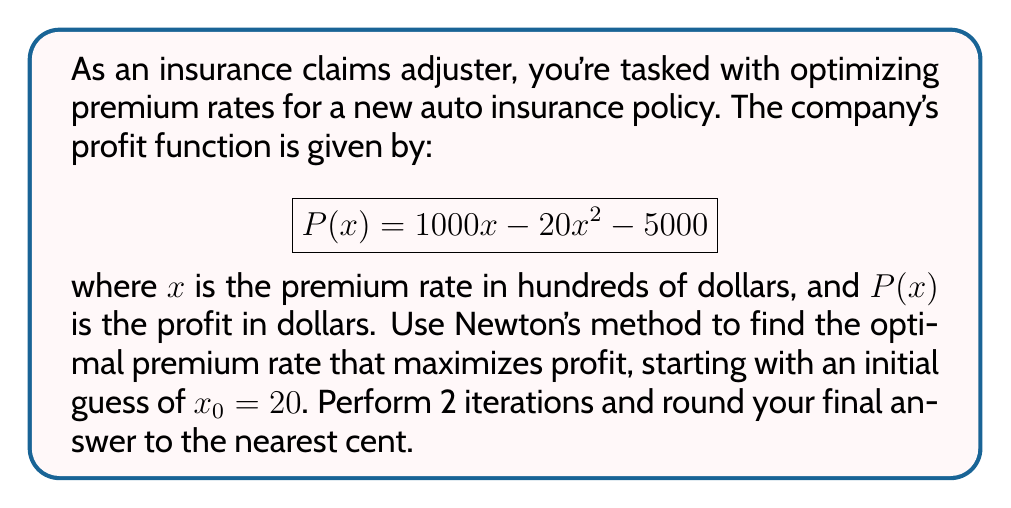What is the answer to this math problem? To find the maximum of the profit function using Newton's method:

1) First, we need to find the derivative of $P(x)$:
   $$P'(x) = 1000 - 40x$$

2) The second derivative is:
   $$P''(x) = -40$$

3) Newton's method formula for optimization:
   $$x_{n+1} = x_n - \frac{P'(x_n)}{P''(x_n)}$$

4) First iteration:
   $$x_1 = 20 - \frac{1000 - 40(20)}{-40} = 20 - \frac{200}{-40} = 20 + 5 = 25$$

5) Second iteration:
   $$x_2 = 25 - \frac{1000 - 40(25)}{-40} = 25 - \frac{0}{-40} = 25$$

6) The optimal premium rate is $25 hundred dollars, or $2,500.

7) To verify this is a maximum, we can check that $P''(x) < 0$:
   $$P''(x) = -40 < 0$$

Therefore, $x = 25$ gives a local maximum.
Answer: $2,500.00 